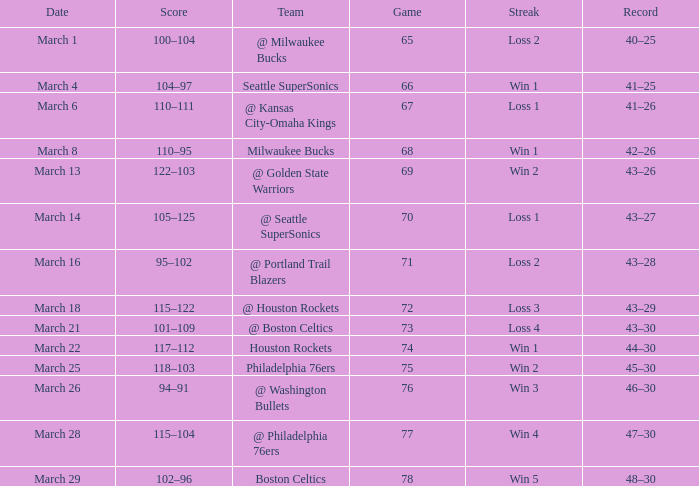What is Team, when Game is 73? @ Boston Celtics. 